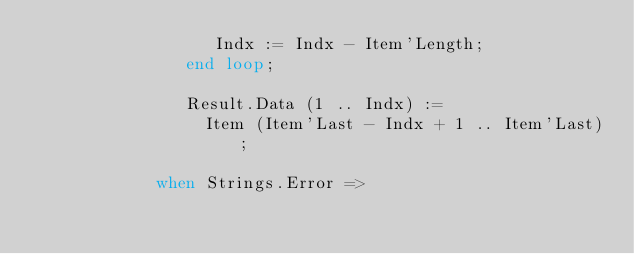Convert code to text. <code><loc_0><loc_0><loc_500><loc_500><_Ada_>                  Indx := Indx - Item'Length;
               end loop;

               Result.Data (1 .. Indx) :=
                 Item (Item'Last - Indx + 1 .. Item'Last);

            when Strings.Error =></code> 